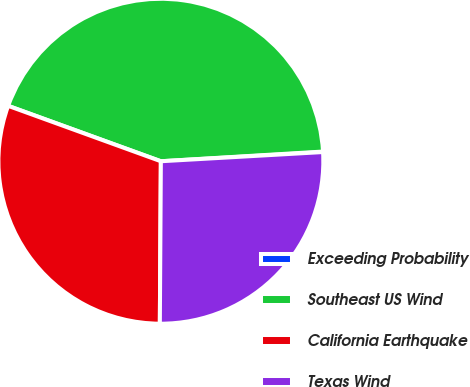<chart> <loc_0><loc_0><loc_500><loc_500><pie_chart><fcel>Exceeding Probability<fcel>Southeast US Wind<fcel>California Earthquake<fcel>Texas Wind<nl><fcel>0.05%<fcel>43.51%<fcel>30.44%<fcel>26.0%<nl></chart> 